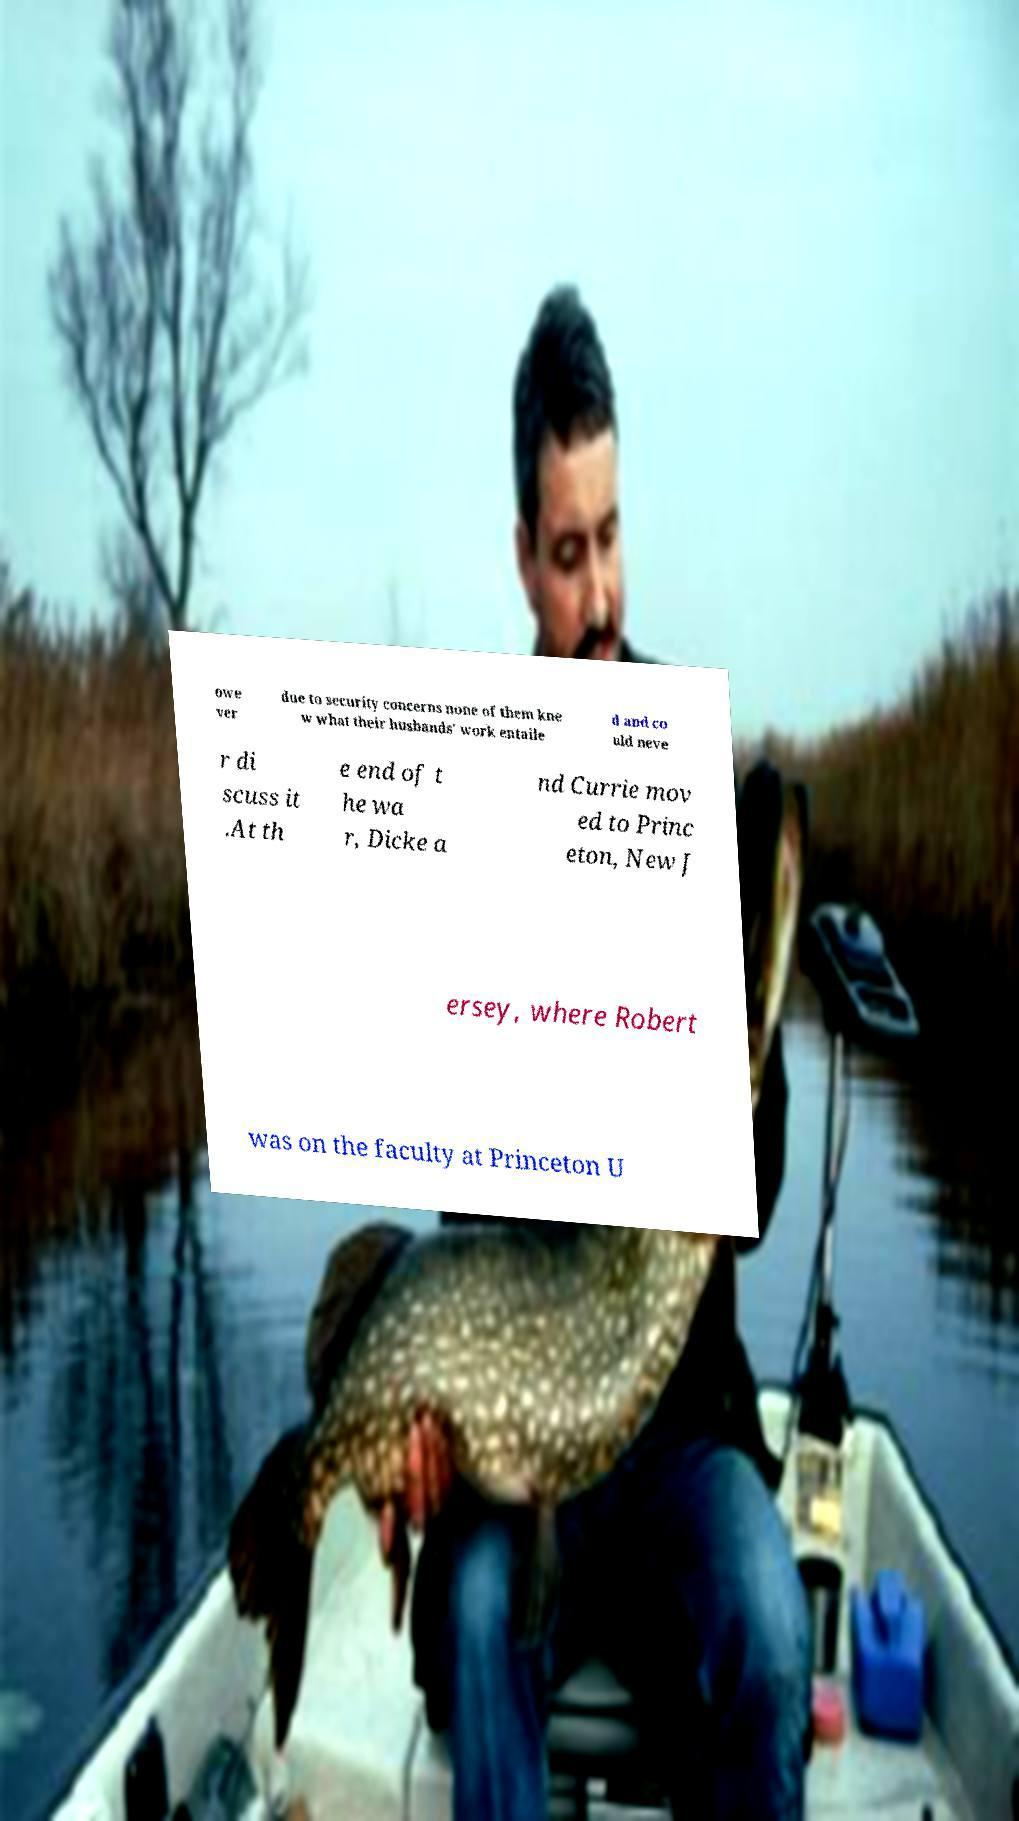Can you accurately transcribe the text from the provided image for me? owe ver due to security concerns none of them kne w what their husbands' work entaile d and co uld neve r di scuss it .At th e end of t he wa r, Dicke a nd Currie mov ed to Princ eton, New J ersey, where Robert was on the faculty at Princeton U 